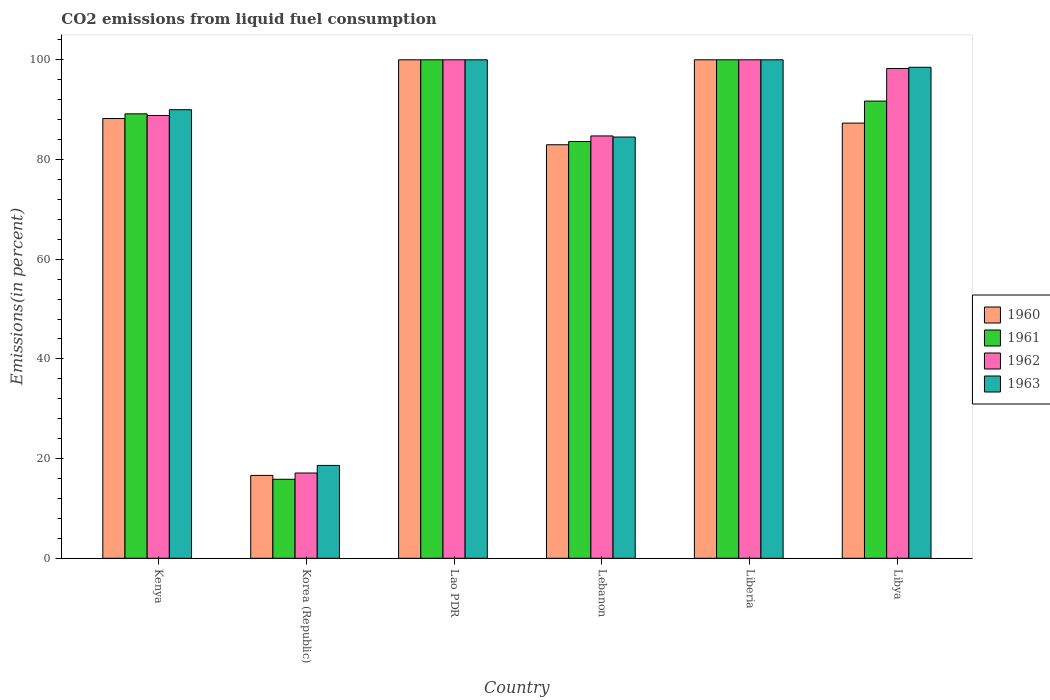Are the number of bars on each tick of the X-axis equal?
Your response must be concise. Yes. How many bars are there on the 3rd tick from the left?
Offer a terse response. 4. How many bars are there on the 6th tick from the right?
Provide a short and direct response. 4. What is the total CO2 emitted in 1963 in Korea (Republic)?
Offer a very short reply. 18.63. Across all countries, what is the maximum total CO2 emitted in 1961?
Give a very brief answer. 100. Across all countries, what is the minimum total CO2 emitted in 1961?
Provide a succinct answer. 15.85. In which country was the total CO2 emitted in 1961 maximum?
Keep it short and to the point. Lao PDR. In which country was the total CO2 emitted in 1960 minimum?
Give a very brief answer. Korea (Republic). What is the total total CO2 emitted in 1960 in the graph?
Your answer should be compact. 475.1. What is the difference between the total CO2 emitted in 1960 in Korea (Republic) and that in Lebanon?
Ensure brevity in your answer.  -66.33. What is the difference between the total CO2 emitted in 1963 in Korea (Republic) and the total CO2 emitted in 1961 in Lebanon?
Your answer should be very brief. -64.98. What is the average total CO2 emitted in 1962 per country?
Make the answer very short. 81.48. What is the difference between the total CO2 emitted of/in 1962 and total CO2 emitted of/in 1961 in Korea (Republic)?
Offer a very short reply. 1.26. What is the ratio of the total CO2 emitted in 1960 in Kenya to that in Lao PDR?
Keep it short and to the point. 0.88. Is the difference between the total CO2 emitted in 1962 in Lao PDR and Libya greater than the difference between the total CO2 emitted in 1961 in Lao PDR and Libya?
Give a very brief answer. No. What is the difference between the highest and the second highest total CO2 emitted in 1961?
Provide a succinct answer. -8.28. What is the difference between the highest and the lowest total CO2 emitted in 1961?
Provide a short and direct response. 84.15. In how many countries, is the total CO2 emitted in 1960 greater than the average total CO2 emitted in 1960 taken over all countries?
Ensure brevity in your answer.  5. Is the sum of the total CO2 emitted in 1962 in Lao PDR and Lebanon greater than the maximum total CO2 emitted in 1961 across all countries?
Provide a short and direct response. Yes. Is it the case that in every country, the sum of the total CO2 emitted in 1963 and total CO2 emitted in 1960 is greater than the sum of total CO2 emitted in 1962 and total CO2 emitted in 1961?
Ensure brevity in your answer.  No. What does the 1st bar from the left in Kenya represents?
Your response must be concise. 1960. What does the 2nd bar from the right in Lao PDR represents?
Offer a terse response. 1962. Is it the case that in every country, the sum of the total CO2 emitted in 1963 and total CO2 emitted in 1960 is greater than the total CO2 emitted in 1961?
Keep it short and to the point. Yes. How many bars are there?
Give a very brief answer. 24. What is the difference between two consecutive major ticks on the Y-axis?
Your answer should be compact. 20. Are the values on the major ticks of Y-axis written in scientific E-notation?
Provide a short and direct response. No. Does the graph contain any zero values?
Provide a succinct answer. No. How many legend labels are there?
Offer a terse response. 4. What is the title of the graph?
Provide a short and direct response. CO2 emissions from liquid fuel consumption. Does "2010" appear as one of the legend labels in the graph?
Your answer should be very brief. No. What is the label or title of the Y-axis?
Offer a terse response. Emissions(in percent). What is the Emissions(in percent) in 1960 in Kenya?
Give a very brief answer. 88.22. What is the Emissions(in percent) of 1961 in Kenya?
Offer a very short reply. 89.16. What is the Emissions(in percent) in 1962 in Kenya?
Your answer should be compact. 88.83. What is the Emissions(in percent) of 1963 in Kenya?
Provide a short and direct response. 89.99. What is the Emissions(in percent) of 1960 in Korea (Republic)?
Your answer should be compact. 16.62. What is the Emissions(in percent) of 1961 in Korea (Republic)?
Provide a succinct answer. 15.85. What is the Emissions(in percent) in 1962 in Korea (Republic)?
Make the answer very short. 17.11. What is the Emissions(in percent) in 1963 in Korea (Republic)?
Your answer should be compact. 18.63. What is the Emissions(in percent) in 1960 in Lao PDR?
Provide a succinct answer. 100. What is the Emissions(in percent) in 1963 in Lao PDR?
Your answer should be compact. 100. What is the Emissions(in percent) of 1960 in Lebanon?
Give a very brief answer. 82.95. What is the Emissions(in percent) of 1961 in Lebanon?
Your response must be concise. 83.61. What is the Emissions(in percent) in 1962 in Lebanon?
Provide a succinct answer. 84.72. What is the Emissions(in percent) in 1963 in Lebanon?
Provide a short and direct response. 84.5. What is the Emissions(in percent) of 1961 in Liberia?
Offer a very short reply. 100. What is the Emissions(in percent) in 1963 in Liberia?
Offer a terse response. 100. What is the Emissions(in percent) in 1960 in Libya?
Keep it short and to the point. 87.3. What is the Emissions(in percent) of 1961 in Libya?
Give a very brief answer. 91.72. What is the Emissions(in percent) of 1962 in Libya?
Offer a very short reply. 98.25. What is the Emissions(in percent) of 1963 in Libya?
Your response must be concise. 98.5. Across all countries, what is the maximum Emissions(in percent) in 1960?
Your response must be concise. 100. Across all countries, what is the maximum Emissions(in percent) of 1962?
Keep it short and to the point. 100. Across all countries, what is the maximum Emissions(in percent) of 1963?
Offer a terse response. 100. Across all countries, what is the minimum Emissions(in percent) of 1960?
Offer a terse response. 16.62. Across all countries, what is the minimum Emissions(in percent) in 1961?
Your answer should be compact. 15.85. Across all countries, what is the minimum Emissions(in percent) in 1962?
Provide a short and direct response. 17.11. Across all countries, what is the minimum Emissions(in percent) in 1963?
Offer a terse response. 18.63. What is the total Emissions(in percent) in 1960 in the graph?
Offer a terse response. 475.1. What is the total Emissions(in percent) in 1961 in the graph?
Your answer should be very brief. 480.33. What is the total Emissions(in percent) in 1962 in the graph?
Your answer should be very brief. 488.91. What is the total Emissions(in percent) in 1963 in the graph?
Ensure brevity in your answer.  491.61. What is the difference between the Emissions(in percent) of 1960 in Kenya and that in Korea (Republic)?
Give a very brief answer. 71.59. What is the difference between the Emissions(in percent) in 1961 in Kenya and that in Korea (Republic)?
Ensure brevity in your answer.  73.31. What is the difference between the Emissions(in percent) of 1962 in Kenya and that in Korea (Republic)?
Provide a short and direct response. 71.72. What is the difference between the Emissions(in percent) of 1963 in Kenya and that in Korea (Republic)?
Offer a terse response. 71.36. What is the difference between the Emissions(in percent) of 1960 in Kenya and that in Lao PDR?
Offer a very short reply. -11.78. What is the difference between the Emissions(in percent) of 1961 in Kenya and that in Lao PDR?
Your answer should be compact. -10.84. What is the difference between the Emissions(in percent) in 1962 in Kenya and that in Lao PDR?
Make the answer very short. -11.17. What is the difference between the Emissions(in percent) of 1963 in Kenya and that in Lao PDR?
Ensure brevity in your answer.  -10.01. What is the difference between the Emissions(in percent) in 1960 in Kenya and that in Lebanon?
Offer a very short reply. 5.26. What is the difference between the Emissions(in percent) of 1961 in Kenya and that in Lebanon?
Offer a terse response. 5.55. What is the difference between the Emissions(in percent) in 1962 in Kenya and that in Lebanon?
Your answer should be very brief. 4.1. What is the difference between the Emissions(in percent) in 1963 in Kenya and that in Lebanon?
Your answer should be compact. 5.48. What is the difference between the Emissions(in percent) of 1960 in Kenya and that in Liberia?
Provide a succinct answer. -11.78. What is the difference between the Emissions(in percent) of 1961 in Kenya and that in Liberia?
Make the answer very short. -10.84. What is the difference between the Emissions(in percent) in 1962 in Kenya and that in Liberia?
Offer a terse response. -11.17. What is the difference between the Emissions(in percent) of 1963 in Kenya and that in Liberia?
Your answer should be compact. -10.01. What is the difference between the Emissions(in percent) in 1960 in Kenya and that in Libya?
Make the answer very short. 0.92. What is the difference between the Emissions(in percent) of 1961 in Kenya and that in Libya?
Make the answer very short. -2.56. What is the difference between the Emissions(in percent) in 1962 in Kenya and that in Libya?
Your answer should be compact. -9.42. What is the difference between the Emissions(in percent) of 1963 in Kenya and that in Libya?
Your response must be concise. -8.51. What is the difference between the Emissions(in percent) in 1960 in Korea (Republic) and that in Lao PDR?
Your answer should be compact. -83.38. What is the difference between the Emissions(in percent) in 1961 in Korea (Republic) and that in Lao PDR?
Keep it short and to the point. -84.15. What is the difference between the Emissions(in percent) in 1962 in Korea (Republic) and that in Lao PDR?
Your answer should be compact. -82.89. What is the difference between the Emissions(in percent) of 1963 in Korea (Republic) and that in Lao PDR?
Make the answer very short. -81.37. What is the difference between the Emissions(in percent) of 1960 in Korea (Republic) and that in Lebanon?
Provide a short and direct response. -66.33. What is the difference between the Emissions(in percent) in 1961 in Korea (Republic) and that in Lebanon?
Give a very brief answer. -67.76. What is the difference between the Emissions(in percent) in 1962 in Korea (Republic) and that in Lebanon?
Provide a succinct answer. -67.62. What is the difference between the Emissions(in percent) in 1963 in Korea (Republic) and that in Lebanon?
Your response must be concise. -65.88. What is the difference between the Emissions(in percent) of 1960 in Korea (Republic) and that in Liberia?
Keep it short and to the point. -83.38. What is the difference between the Emissions(in percent) in 1961 in Korea (Republic) and that in Liberia?
Make the answer very short. -84.15. What is the difference between the Emissions(in percent) in 1962 in Korea (Republic) and that in Liberia?
Your response must be concise. -82.89. What is the difference between the Emissions(in percent) of 1963 in Korea (Republic) and that in Liberia?
Ensure brevity in your answer.  -81.37. What is the difference between the Emissions(in percent) of 1960 in Korea (Republic) and that in Libya?
Offer a terse response. -70.68. What is the difference between the Emissions(in percent) of 1961 in Korea (Republic) and that in Libya?
Offer a terse response. -75.87. What is the difference between the Emissions(in percent) in 1962 in Korea (Republic) and that in Libya?
Offer a very short reply. -81.15. What is the difference between the Emissions(in percent) in 1963 in Korea (Republic) and that in Libya?
Make the answer very short. -79.87. What is the difference between the Emissions(in percent) of 1960 in Lao PDR and that in Lebanon?
Your answer should be compact. 17.05. What is the difference between the Emissions(in percent) in 1961 in Lao PDR and that in Lebanon?
Make the answer very short. 16.39. What is the difference between the Emissions(in percent) in 1962 in Lao PDR and that in Lebanon?
Offer a very short reply. 15.28. What is the difference between the Emissions(in percent) of 1963 in Lao PDR and that in Lebanon?
Keep it short and to the point. 15.5. What is the difference between the Emissions(in percent) of 1960 in Lao PDR and that in Liberia?
Your response must be concise. 0. What is the difference between the Emissions(in percent) in 1961 in Lao PDR and that in Liberia?
Provide a short and direct response. 0. What is the difference between the Emissions(in percent) of 1963 in Lao PDR and that in Liberia?
Keep it short and to the point. 0. What is the difference between the Emissions(in percent) of 1960 in Lao PDR and that in Libya?
Your response must be concise. 12.7. What is the difference between the Emissions(in percent) of 1961 in Lao PDR and that in Libya?
Keep it short and to the point. 8.28. What is the difference between the Emissions(in percent) of 1962 in Lao PDR and that in Libya?
Offer a very short reply. 1.75. What is the difference between the Emissions(in percent) in 1963 in Lao PDR and that in Libya?
Ensure brevity in your answer.  1.5. What is the difference between the Emissions(in percent) of 1960 in Lebanon and that in Liberia?
Offer a very short reply. -17.05. What is the difference between the Emissions(in percent) in 1961 in Lebanon and that in Liberia?
Provide a succinct answer. -16.39. What is the difference between the Emissions(in percent) in 1962 in Lebanon and that in Liberia?
Your answer should be compact. -15.28. What is the difference between the Emissions(in percent) of 1963 in Lebanon and that in Liberia?
Provide a short and direct response. -15.5. What is the difference between the Emissions(in percent) in 1960 in Lebanon and that in Libya?
Ensure brevity in your answer.  -4.35. What is the difference between the Emissions(in percent) in 1961 in Lebanon and that in Libya?
Your answer should be very brief. -8.11. What is the difference between the Emissions(in percent) of 1962 in Lebanon and that in Libya?
Offer a very short reply. -13.53. What is the difference between the Emissions(in percent) of 1963 in Lebanon and that in Libya?
Offer a terse response. -13.99. What is the difference between the Emissions(in percent) in 1960 in Liberia and that in Libya?
Provide a short and direct response. 12.7. What is the difference between the Emissions(in percent) of 1961 in Liberia and that in Libya?
Your answer should be compact. 8.28. What is the difference between the Emissions(in percent) of 1962 in Liberia and that in Libya?
Ensure brevity in your answer.  1.75. What is the difference between the Emissions(in percent) of 1963 in Liberia and that in Libya?
Offer a terse response. 1.5. What is the difference between the Emissions(in percent) of 1960 in Kenya and the Emissions(in percent) of 1961 in Korea (Republic)?
Make the answer very short. 72.37. What is the difference between the Emissions(in percent) in 1960 in Kenya and the Emissions(in percent) in 1962 in Korea (Republic)?
Provide a short and direct response. 71.11. What is the difference between the Emissions(in percent) in 1960 in Kenya and the Emissions(in percent) in 1963 in Korea (Republic)?
Your answer should be compact. 69.59. What is the difference between the Emissions(in percent) in 1961 in Kenya and the Emissions(in percent) in 1962 in Korea (Republic)?
Your answer should be very brief. 72.06. What is the difference between the Emissions(in percent) in 1961 in Kenya and the Emissions(in percent) in 1963 in Korea (Republic)?
Your answer should be very brief. 70.53. What is the difference between the Emissions(in percent) in 1962 in Kenya and the Emissions(in percent) in 1963 in Korea (Republic)?
Offer a terse response. 70.2. What is the difference between the Emissions(in percent) in 1960 in Kenya and the Emissions(in percent) in 1961 in Lao PDR?
Your answer should be compact. -11.78. What is the difference between the Emissions(in percent) in 1960 in Kenya and the Emissions(in percent) in 1962 in Lao PDR?
Give a very brief answer. -11.78. What is the difference between the Emissions(in percent) of 1960 in Kenya and the Emissions(in percent) of 1963 in Lao PDR?
Your answer should be compact. -11.78. What is the difference between the Emissions(in percent) in 1961 in Kenya and the Emissions(in percent) in 1962 in Lao PDR?
Your answer should be very brief. -10.84. What is the difference between the Emissions(in percent) of 1961 in Kenya and the Emissions(in percent) of 1963 in Lao PDR?
Your answer should be very brief. -10.84. What is the difference between the Emissions(in percent) in 1962 in Kenya and the Emissions(in percent) in 1963 in Lao PDR?
Your response must be concise. -11.17. What is the difference between the Emissions(in percent) of 1960 in Kenya and the Emissions(in percent) of 1961 in Lebanon?
Provide a short and direct response. 4.61. What is the difference between the Emissions(in percent) in 1960 in Kenya and the Emissions(in percent) in 1962 in Lebanon?
Provide a short and direct response. 3.49. What is the difference between the Emissions(in percent) in 1960 in Kenya and the Emissions(in percent) in 1963 in Lebanon?
Offer a terse response. 3.71. What is the difference between the Emissions(in percent) in 1961 in Kenya and the Emissions(in percent) in 1962 in Lebanon?
Provide a short and direct response. 4.44. What is the difference between the Emissions(in percent) in 1961 in Kenya and the Emissions(in percent) in 1963 in Lebanon?
Your answer should be very brief. 4.66. What is the difference between the Emissions(in percent) in 1962 in Kenya and the Emissions(in percent) in 1963 in Lebanon?
Make the answer very short. 4.32. What is the difference between the Emissions(in percent) in 1960 in Kenya and the Emissions(in percent) in 1961 in Liberia?
Provide a short and direct response. -11.78. What is the difference between the Emissions(in percent) in 1960 in Kenya and the Emissions(in percent) in 1962 in Liberia?
Make the answer very short. -11.78. What is the difference between the Emissions(in percent) of 1960 in Kenya and the Emissions(in percent) of 1963 in Liberia?
Keep it short and to the point. -11.78. What is the difference between the Emissions(in percent) in 1961 in Kenya and the Emissions(in percent) in 1962 in Liberia?
Keep it short and to the point. -10.84. What is the difference between the Emissions(in percent) of 1961 in Kenya and the Emissions(in percent) of 1963 in Liberia?
Make the answer very short. -10.84. What is the difference between the Emissions(in percent) in 1962 in Kenya and the Emissions(in percent) in 1963 in Liberia?
Your answer should be compact. -11.17. What is the difference between the Emissions(in percent) in 1960 in Kenya and the Emissions(in percent) in 1961 in Libya?
Ensure brevity in your answer.  -3.5. What is the difference between the Emissions(in percent) in 1960 in Kenya and the Emissions(in percent) in 1962 in Libya?
Keep it short and to the point. -10.03. What is the difference between the Emissions(in percent) in 1960 in Kenya and the Emissions(in percent) in 1963 in Libya?
Ensure brevity in your answer.  -10.28. What is the difference between the Emissions(in percent) of 1961 in Kenya and the Emissions(in percent) of 1962 in Libya?
Keep it short and to the point. -9.09. What is the difference between the Emissions(in percent) of 1961 in Kenya and the Emissions(in percent) of 1963 in Libya?
Ensure brevity in your answer.  -9.34. What is the difference between the Emissions(in percent) in 1962 in Kenya and the Emissions(in percent) in 1963 in Libya?
Offer a very short reply. -9.67. What is the difference between the Emissions(in percent) of 1960 in Korea (Republic) and the Emissions(in percent) of 1961 in Lao PDR?
Make the answer very short. -83.38. What is the difference between the Emissions(in percent) in 1960 in Korea (Republic) and the Emissions(in percent) in 1962 in Lao PDR?
Your answer should be very brief. -83.38. What is the difference between the Emissions(in percent) in 1960 in Korea (Republic) and the Emissions(in percent) in 1963 in Lao PDR?
Keep it short and to the point. -83.38. What is the difference between the Emissions(in percent) in 1961 in Korea (Republic) and the Emissions(in percent) in 1962 in Lao PDR?
Offer a terse response. -84.15. What is the difference between the Emissions(in percent) of 1961 in Korea (Republic) and the Emissions(in percent) of 1963 in Lao PDR?
Make the answer very short. -84.15. What is the difference between the Emissions(in percent) in 1962 in Korea (Republic) and the Emissions(in percent) in 1963 in Lao PDR?
Your answer should be compact. -82.89. What is the difference between the Emissions(in percent) in 1960 in Korea (Republic) and the Emissions(in percent) in 1961 in Lebanon?
Your response must be concise. -66.98. What is the difference between the Emissions(in percent) of 1960 in Korea (Republic) and the Emissions(in percent) of 1962 in Lebanon?
Make the answer very short. -68.1. What is the difference between the Emissions(in percent) in 1960 in Korea (Republic) and the Emissions(in percent) in 1963 in Lebanon?
Provide a succinct answer. -67.88. What is the difference between the Emissions(in percent) of 1961 in Korea (Republic) and the Emissions(in percent) of 1962 in Lebanon?
Offer a very short reply. -68.88. What is the difference between the Emissions(in percent) in 1961 in Korea (Republic) and the Emissions(in percent) in 1963 in Lebanon?
Keep it short and to the point. -68.66. What is the difference between the Emissions(in percent) in 1962 in Korea (Republic) and the Emissions(in percent) in 1963 in Lebanon?
Ensure brevity in your answer.  -67.4. What is the difference between the Emissions(in percent) of 1960 in Korea (Republic) and the Emissions(in percent) of 1961 in Liberia?
Make the answer very short. -83.38. What is the difference between the Emissions(in percent) of 1960 in Korea (Republic) and the Emissions(in percent) of 1962 in Liberia?
Your response must be concise. -83.38. What is the difference between the Emissions(in percent) in 1960 in Korea (Republic) and the Emissions(in percent) in 1963 in Liberia?
Offer a very short reply. -83.38. What is the difference between the Emissions(in percent) in 1961 in Korea (Republic) and the Emissions(in percent) in 1962 in Liberia?
Keep it short and to the point. -84.15. What is the difference between the Emissions(in percent) of 1961 in Korea (Republic) and the Emissions(in percent) of 1963 in Liberia?
Your answer should be compact. -84.15. What is the difference between the Emissions(in percent) in 1962 in Korea (Republic) and the Emissions(in percent) in 1963 in Liberia?
Give a very brief answer. -82.89. What is the difference between the Emissions(in percent) in 1960 in Korea (Republic) and the Emissions(in percent) in 1961 in Libya?
Offer a terse response. -75.09. What is the difference between the Emissions(in percent) in 1960 in Korea (Republic) and the Emissions(in percent) in 1962 in Libya?
Provide a succinct answer. -81.63. What is the difference between the Emissions(in percent) in 1960 in Korea (Republic) and the Emissions(in percent) in 1963 in Libya?
Provide a short and direct response. -81.87. What is the difference between the Emissions(in percent) of 1961 in Korea (Republic) and the Emissions(in percent) of 1962 in Libya?
Your answer should be very brief. -82.4. What is the difference between the Emissions(in percent) in 1961 in Korea (Republic) and the Emissions(in percent) in 1963 in Libya?
Offer a very short reply. -82.65. What is the difference between the Emissions(in percent) in 1962 in Korea (Republic) and the Emissions(in percent) in 1963 in Libya?
Provide a short and direct response. -81.39. What is the difference between the Emissions(in percent) in 1960 in Lao PDR and the Emissions(in percent) in 1961 in Lebanon?
Your answer should be very brief. 16.39. What is the difference between the Emissions(in percent) of 1960 in Lao PDR and the Emissions(in percent) of 1962 in Lebanon?
Provide a succinct answer. 15.28. What is the difference between the Emissions(in percent) of 1960 in Lao PDR and the Emissions(in percent) of 1963 in Lebanon?
Make the answer very short. 15.5. What is the difference between the Emissions(in percent) in 1961 in Lao PDR and the Emissions(in percent) in 1962 in Lebanon?
Your response must be concise. 15.28. What is the difference between the Emissions(in percent) of 1961 in Lao PDR and the Emissions(in percent) of 1963 in Lebanon?
Your answer should be compact. 15.5. What is the difference between the Emissions(in percent) of 1962 in Lao PDR and the Emissions(in percent) of 1963 in Lebanon?
Offer a terse response. 15.5. What is the difference between the Emissions(in percent) of 1960 in Lao PDR and the Emissions(in percent) of 1961 in Liberia?
Offer a terse response. 0. What is the difference between the Emissions(in percent) in 1960 in Lao PDR and the Emissions(in percent) in 1962 in Liberia?
Keep it short and to the point. 0. What is the difference between the Emissions(in percent) of 1960 in Lao PDR and the Emissions(in percent) of 1963 in Liberia?
Offer a terse response. 0. What is the difference between the Emissions(in percent) of 1961 in Lao PDR and the Emissions(in percent) of 1962 in Liberia?
Keep it short and to the point. 0. What is the difference between the Emissions(in percent) in 1962 in Lao PDR and the Emissions(in percent) in 1963 in Liberia?
Make the answer very short. 0. What is the difference between the Emissions(in percent) in 1960 in Lao PDR and the Emissions(in percent) in 1961 in Libya?
Offer a terse response. 8.28. What is the difference between the Emissions(in percent) in 1960 in Lao PDR and the Emissions(in percent) in 1962 in Libya?
Make the answer very short. 1.75. What is the difference between the Emissions(in percent) of 1960 in Lao PDR and the Emissions(in percent) of 1963 in Libya?
Your answer should be compact. 1.5. What is the difference between the Emissions(in percent) of 1961 in Lao PDR and the Emissions(in percent) of 1962 in Libya?
Give a very brief answer. 1.75. What is the difference between the Emissions(in percent) of 1961 in Lao PDR and the Emissions(in percent) of 1963 in Libya?
Make the answer very short. 1.5. What is the difference between the Emissions(in percent) of 1962 in Lao PDR and the Emissions(in percent) of 1963 in Libya?
Give a very brief answer. 1.5. What is the difference between the Emissions(in percent) of 1960 in Lebanon and the Emissions(in percent) of 1961 in Liberia?
Your answer should be very brief. -17.05. What is the difference between the Emissions(in percent) of 1960 in Lebanon and the Emissions(in percent) of 1962 in Liberia?
Give a very brief answer. -17.05. What is the difference between the Emissions(in percent) in 1960 in Lebanon and the Emissions(in percent) in 1963 in Liberia?
Your answer should be compact. -17.05. What is the difference between the Emissions(in percent) of 1961 in Lebanon and the Emissions(in percent) of 1962 in Liberia?
Make the answer very short. -16.39. What is the difference between the Emissions(in percent) of 1961 in Lebanon and the Emissions(in percent) of 1963 in Liberia?
Ensure brevity in your answer.  -16.39. What is the difference between the Emissions(in percent) in 1962 in Lebanon and the Emissions(in percent) in 1963 in Liberia?
Keep it short and to the point. -15.28. What is the difference between the Emissions(in percent) in 1960 in Lebanon and the Emissions(in percent) in 1961 in Libya?
Give a very brief answer. -8.76. What is the difference between the Emissions(in percent) of 1960 in Lebanon and the Emissions(in percent) of 1962 in Libya?
Make the answer very short. -15.3. What is the difference between the Emissions(in percent) in 1960 in Lebanon and the Emissions(in percent) in 1963 in Libya?
Your answer should be compact. -15.54. What is the difference between the Emissions(in percent) of 1961 in Lebanon and the Emissions(in percent) of 1962 in Libya?
Your answer should be compact. -14.65. What is the difference between the Emissions(in percent) in 1961 in Lebanon and the Emissions(in percent) in 1963 in Libya?
Your response must be concise. -14.89. What is the difference between the Emissions(in percent) of 1962 in Lebanon and the Emissions(in percent) of 1963 in Libya?
Your answer should be very brief. -13.77. What is the difference between the Emissions(in percent) in 1960 in Liberia and the Emissions(in percent) in 1961 in Libya?
Provide a succinct answer. 8.28. What is the difference between the Emissions(in percent) of 1960 in Liberia and the Emissions(in percent) of 1962 in Libya?
Give a very brief answer. 1.75. What is the difference between the Emissions(in percent) in 1960 in Liberia and the Emissions(in percent) in 1963 in Libya?
Provide a succinct answer. 1.5. What is the difference between the Emissions(in percent) in 1961 in Liberia and the Emissions(in percent) in 1962 in Libya?
Your answer should be compact. 1.75. What is the difference between the Emissions(in percent) in 1961 in Liberia and the Emissions(in percent) in 1963 in Libya?
Provide a short and direct response. 1.5. What is the difference between the Emissions(in percent) of 1962 in Liberia and the Emissions(in percent) of 1963 in Libya?
Your response must be concise. 1.5. What is the average Emissions(in percent) of 1960 per country?
Provide a short and direct response. 79.18. What is the average Emissions(in percent) in 1961 per country?
Offer a very short reply. 80.06. What is the average Emissions(in percent) in 1962 per country?
Keep it short and to the point. 81.48. What is the average Emissions(in percent) of 1963 per country?
Provide a succinct answer. 81.94. What is the difference between the Emissions(in percent) in 1960 and Emissions(in percent) in 1961 in Kenya?
Offer a terse response. -0.94. What is the difference between the Emissions(in percent) in 1960 and Emissions(in percent) in 1962 in Kenya?
Give a very brief answer. -0.61. What is the difference between the Emissions(in percent) of 1960 and Emissions(in percent) of 1963 in Kenya?
Provide a short and direct response. -1.77. What is the difference between the Emissions(in percent) of 1961 and Emissions(in percent) of 1962 in Kenya?
Provide a succinct answer. 0.33. What is the difference between the Emissions(in percent) in 1961 and Emissions(in percent) in 1963 in Kenya?
Give a very brief answer. -0.83. What is the difference between the Emissions(in percent) of 1962 and Emissions(in percent) of 1963 in Kenya?
Offer a very short reply. -1.16. What is the difference between the Emissions(in percent) of 1960 and Emissions(in percent) of 1961 in Korea (Republic)?
Ensure brevity in your answer.  0.78. What is the difference between the Emissions(in percent) of 1960 and Emissions(in percent) of 1962 in Korea (Republic)?
Your response must be concise. -0.48. What is the difference between the Emissions(in percent) in 1960 and Emissions(in percent) in 1963 in Korea (Republic)?
Keep it short and to the point. -2. What is the difference between the Emissions(in percent) of 1961 and Emissions(in percent) of 1962 in Korea (Republic)?
Provide a succinct answer. -1.26. What is the difference between the Emissions(in percent) in 1961 and Emissions(in percent) in 1963 in Korea (Republic)?
Provide a succinct answer. -2.78. What is the difference between the Emissions(in percent) in 1962 and Emissions(in percent) in 1963 in Korea (Republic)?
Give a very brief answer. -1.52. What is the difference between the Emissions(in percent) of 1960 and Emissions(in percent) of 1962 in Lao PDR?
Offer a terse response. 0. What is the difference between the Emissions(in percent) of 1960 and Emissions(in percent) of 1963 in Lao PDR?
Keep it short and to the point. 0. What is the difference between the Emissions(in percent) in 1961 and Emissions(in percent) in 1962 in Lao PDR?
Your answer should be compact. 0. What is the difference between the Emissions(in percent) in 1960 and Emissions(in percent) in 1961 in Lebanon?
Your response must be concise. -0.65. What is the difference between the Emissions(in percent) of 1960 and Emissions(in percent) of 1962 in Lebanon?
Your answer should be very brief. -1.77. What is the difference between the Emissions(in percent) in 1960 and Emissions(in percent) in 1963 in Lebanon?
Ensure brevity in your answer.  -1.55. What is the difference between the Emissions(in percent) of 1961 and Emissions(in percent) of 1962 in Lebanon?
Offer a very short reply. -1.12. What is the difference between the Emissions(in percent) in 1961 and Emissions(in percent) in 1963 in Lebanon?
Offer a very short reply. -0.9. What is the difference between the Emissions(in percent) in 1962 and Emissions(in percent) in 1963 in Lebanon?
Ensure brevity in your answer.  0.22. What is the difference between the Emissions(in percent) in 1960 and Emissions(in percent) in 1961 in Liberia?
Provide a short and direct response. 0. What is the difference between the Emissions(in percent) in 1961 and Emissions(in percent) in 1962 in Liberia?
Make the answer very short. 0. What is the difference between the Emissions(in percent) in 1960 and Emissions(in percent) in 1961 in Libya?
Give a very brief answer. -4.42. What is the difference between the Emissions(in percent) in 1960 and Emissions(in percent) in 1962 in Libya?
Provide a succinct answer. -10.95. What is the difference between the Emissions(in percent) in 1960 and Emissions(in percent) in 1963 in Libya?
Your answer should be very brief. -11.19. What is the difference between the Emissions(in percent) of 1961 and Emissions(in percent) of 1962 in Libya?
Your answer should be compact. -6.53. What is the difference between the Emissions(in percent) in 1961 and Emissions(in percent) in 1963 in Libya?
Make the answer very short. -6.78. What is the difference between the Emissions(in percent) of 1962 and Emissions(in percent) of 1963 in Libya?
Give a very brief answer. -0.24. What is the ratio of the Emissions(in percent) of 1960 in Kenya to that in Korea (Republic)?
Offer a very short reply. 5.31. What is the ratio of the Emissions(in percent) in 1961 in Kenya to that in Korea (Republic)?
Your answer should be compact. 5.63. What is the ratio of the Emissions(in percent) in 1962 in Kenya to that in Korea (Republic)?
Offer a very short reply. 5.19. What is the ratio of the Emissions(in percent) in 1963 in Kenya to that in Korea (Republic)?
Provide a short and direct response. 4.83. What is the ratio of the Emissions(in percent) of 1960 in Kenya to that in Lao PDR?
Provide a short and direct response. 0.88. What is the ratio of the Emissions(in percent) of 1961 in Kenya to that in Lao PDR?
Give a very brief answer. 0.89. What is the ratio of the Emissions(in percent) in 1962 in Kenya to that in Lao PDR?
Ensure brevity in your answer.  0.89. What is the ratio of the Emissions(in percent) in 1963 in Kenya to that in Lao PDR?
Make the answer very short. 0.9. What is the ratio of the Emissions(in percent) of 1960 in Kenya to that in Lebanon?
Your answer should be very brief. 1.06. What is the ratio of the Emissions(in percent) in 1961 in Kenya to that in Lebanon?
Make the answer very short. 1.07. What is the ratio of the Emissions(in percent) in 1962 in Kenya to that in Lebanon?
Provide a succinct answer. 1.05. What is the ratio of the Emissions(in percent) of 1963 in Kenya to that in Lebanon?
Your answer should be compact. 1.06. What is the ratio of the Emissions(in percent) of 1960 in Kenya to that in Liberia?
Provide a succinct answer. 0.88. What is the ratio of the Emissions(in percent) in 1961 in Kenya to that in Liberia?
Give a very brief answer. 0.89. What is the ratio of the Emissions(in percent) in 1962 in Kenya to that in Liberia?
Ensure brevity in your answer.  0.89. What is the ratio of the Emissions(in percent) in 1963 in Kenya to that in Liberia?
Your answer should be compact. 0.9. What is the ratio of the Emissions(in percent) of 1960 in Kenya to that in Libya?
Give a very brief answer. 1.01. What is the ratio of the Emissions(in percent) in 1961 in Kenya to that in Libya?
Give a very brief answer. 0.97. What is the ratio of the Emissions(in percent) in 1962 in Kenya to that in Libya?
Offer a very short reply. 0.9. What is the ratio of the Emissions(in percent) of 1963 in Kenya to that in Libya?
Offer a terse response. 0.91. What is the ratio of the Emissions(in percent) in 1960 in Korea (Republic) to that in Lao PDR?
Keep it short and to the point. 0.17. What is the ratio of the Emissions(in percent) in 1961 in Korea (Republic) to that in Lao PDR?
Offer a very short reply. 0.16. What is the ratio of the Emissions(in percent) in 1962 in Korea (Republic) to that in Lao PDR?
Your answer should be very brief. 0.17. What is the ratio of the Emissions(in percent) in 1963 in Korea (Republic) to that in Lao PDR?
Provide a succinct answer. 0.19. What is the ratio of the Emissions(in percent) of 1960 in Korea (Republic) to that in Lebanon?
Your answer should be very brief. 0.2. What is the ratio of the Emissions(in percent) of 1961 in Korea (Republic) to that in Lebanon?
Make the answer very short. 0.19. What is the ratio of the Emissions(in percent) in 1962 in Korea (Republic) to that in Lebanon?
Make the answer very short. 0.2. What is the ratio of the Emissions(in percent) of 1963 in Korea (Republic) to that in Lebanon?
Provide a succinct answer. 0.22. What is the ratio of the Emissions(in percent) in 1960 in Korea (Republic) to that in Liberia?
Provide a succinct answer. 0.17. What is the ratio of the Emissions(in percent) in 1961 in Korea (Republic) to that in Liberia?
Offer a very short reply. 0.16. What is the ratio of the Emissions(in percent) in 1962 in Korea (Republic) to that in Liberia?
Ensure brevity in your answer.  0.17. What is the ratio of the Emissions(in percent) of 1963 in Korea (Republic) to that in Liberia?
Keep it short and to the point. 0.19. What is the ratio of the Emissions(in percent) in 1960 in Korea (Republic) to that in Libya?
Your answer should be very brief. 0.19. What is the ratio of the Emissions(in percent) of 1961 in Korea (Republic) to that in Libya?
Your answer should be compact. 0.17. What is the ratio of the Emissions(in percent) of 1962 in Korea (Republic) to that in Libya?
Offer a very short reply. 0.17. What is the ratio of the Emissions(in percent) of 1963 in Korea (Republic) to that in Libya?
Offer a very short reply. 0.19. What is the ratio of the Emissions(in percent) of 1960 in Lao PDR to that in Lebanon?
Ensure brevity in your answer.  1.21. What is the ratio of the Emissions(in percent) of 1961 in Lao PDR to that in Lebanon?
Your answer should be compact. 1.2. What is the ratio of the Emissions(in percent) in 1962 in Lao PDR to that in Lebanon?
Your answer should be very brief. 1.18. What is the ratio of the Emissions(in percent) of 1963 in Lao PDR to that in Lebanon?
Ensure brevity in your answer.  1.18. What is the ratio of the Emissions(in percent) of 1963 in Lao PDR to that in Liberia?
Your response must be concise. 1. What is the ratio of the Emissions(in percent) of 1960 in Lao PDR to that in Libya?
Your answer should be very brief. 1.15. What is the ratio of the Emissions(in percent) in 1961 in Lao PDR to that in Libya?
Your answer should be compact. 1.09. What is the ratio of the Emissions(in percent) in 1962 in Lao PDR to that in Libya?
Your answer should be very brief. 1.02. What is the ratio of the Emissions(in percent) of 1963 in Lao PDR to that in Libya?
Make the answer very short. 1.02. What is the ratio of the Emissions(in percent) of 1960 in Lebanon to that in Liberia?
Offer a terse response. 0.83. What is the ratio of the Emissions(in percent) in 1961 in Lebanon to that in Liberia?
Provide a short and direct response. 0.84. What is the ratio of the Emissions(in percent) of 1962 in Lebanon to that in Liberia?
Your answer should be compact. 0.85. What is the ratio of the Emissions(in percent) in 1963 in Lebanon to that in Liberia?
Your answer should be very brief. 0.84. What is the ratio of the Emissions(in percent) of 1960 in Lebanon to that in Libya?
Provide a short and direct response. 0.95. What is the ratio of the Emissions(in percent) of 1961 in Lebanon to that in Libya?
Provide a succinct answer. 0.91. What is the ratio of the Emissions(in percent) in 1962 in Lebanon to that in Libya?
Ensure brevity in your answer.  0.86. What is the ratio of the Emissions(in percent) in 1963 in Lebanon to that in Libya?
Give a very brief answer. 0.86. What is the ratio of the Emissions(in percent) in 1960 in Liberia to that in Libya?
Provide a short and direct response. 1.15. What is the ratio of the Emissions(in percent) of 1961 in Liberia to that in Libya?
Provide a short and direct response. 1.09. What is the ratio of the Emissions(in percent) of 1962 in Liberia to that in Libya?
Give a very brief answer. 1.02. What is the ratio of the Emissions(in percent) of 1963 in Liberia to that in Libya?
Keep it short and to the point. 1.02. What is the difference between the highest and the second highest Emissions(in percent) of 1962?
Your answer should be compact. 0. What is the difference between the highest and the lowest Emissions(in percent) in 1960?
Your answer should be very brief. 83.38. What is the difference between the highest and the lowest Emissions(in percent) of 1961?
Ensure brevity in your answer.  84.15. What is the difference between the highest and the lowest Emissions(in percent) in 1962?
Give a very brief answer. 82.89. What is the difference between the highest and the lowest Emissions(in percent) in 1963?
Provide a short and direct response. 81.37. 